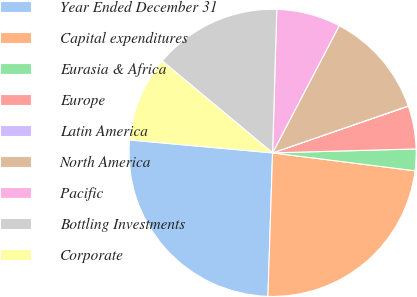Convert chart to OTSL. <chart><loc_0><loc_0><loc_500><loc_500><pie_chart><fcel>Year Ended December 31<fcel>Capital expenditures<fcel>Eurasia & Africa<fcel>Europe<fcel>Latin America<fcel>North America<fcel>Pacific<fcel>Bottling Investments<fcel>Corporate<nl><fcel>25.92%<fcel>23.52%<fcel>2.43%<fcel>4.83%<fcel>0.03%<fcel>12.02%<fcel>7.22%<fcel>14.41%<fcel>9.62%<nl></chart> 